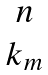Convert formula to latex. <formula><loc_0><loc_0><loc_500><loc_500>\begin{matrix} n \\ k _ { m } \end{matrix}</formula> 